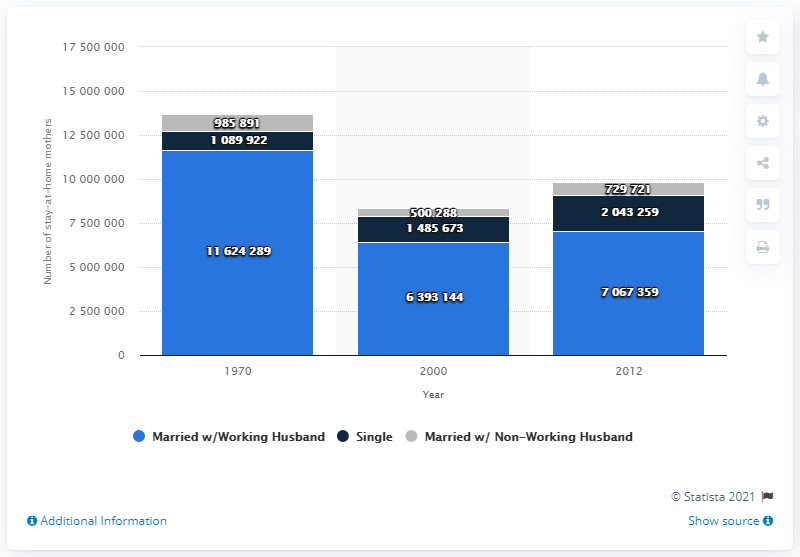Identify some key points in this picture. In 1970, the number of stay-at-home mothers was approximately 116,242,890. 